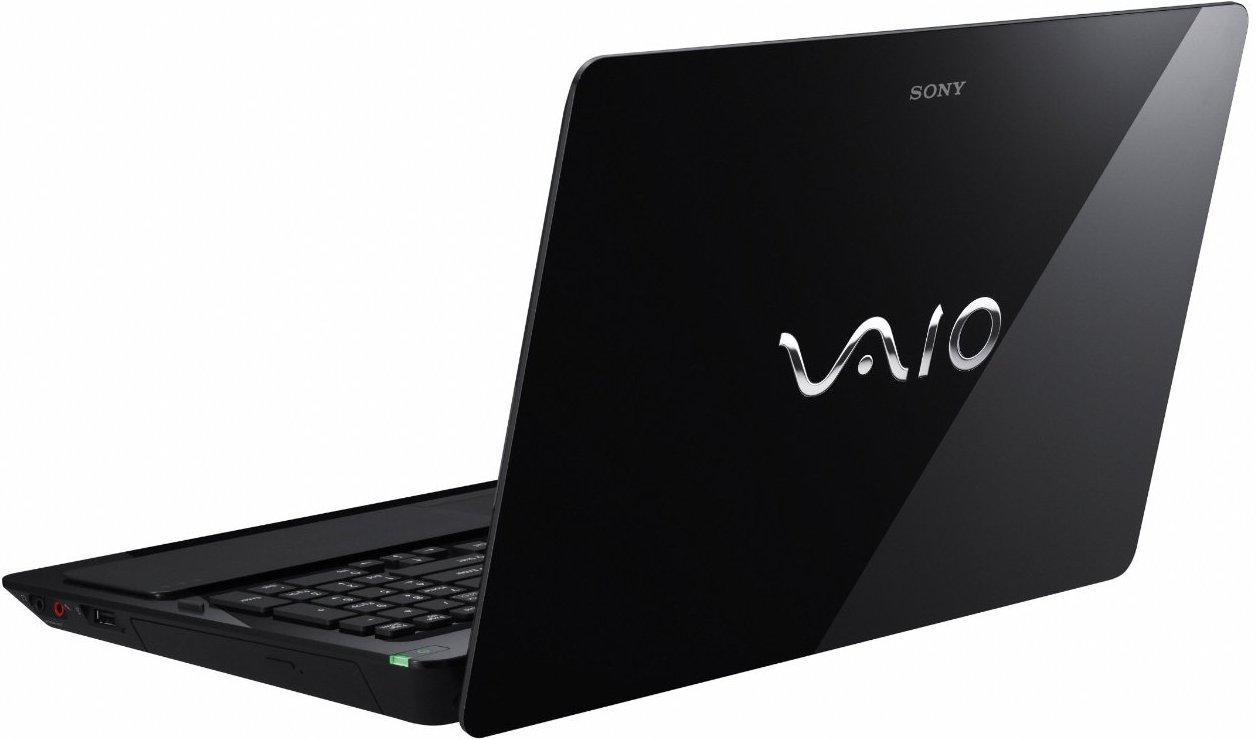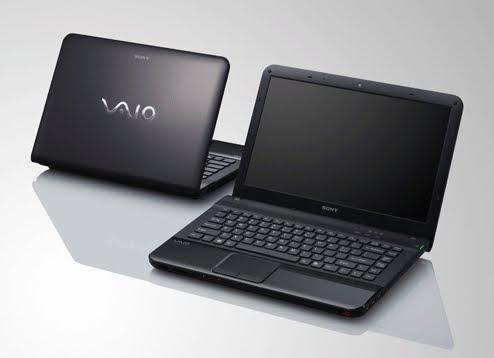The first image is the image on the left, the second image is the image on the right. For the images shown, is this caption "There are three laptops, and every visible screen is black." true? Answer yes or no. Yes. The first image is the image on the left, the second image is the image on the right. For the images displayed, is the sentence "There is exactly two lap tops in the left image." factually correct? Answer yes or no. No. 